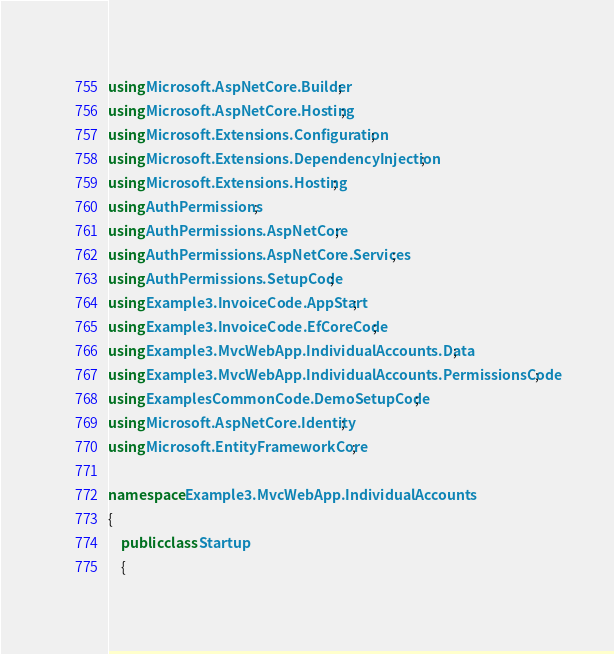Convert code to text. <code><loc_0><loc_0><loc_500><loc_500><_C#_>using Microsoft.AspNetCore.Builder;
using Microsoft.AspNetCore.Hosting;
using Microsoft.Extensions.Configuration;
using Microsoft.Extensions.DependencyInjection;
using Microsoft.Extensions.Hosting;
using AuthPermissions;
using AuthPermissions.AspNetCore;
using AuthPermissions.AspNetCore.Services;
using AuthPermissions.SetupCode;
using Example3.InvoiceCode.AppStart;
using Example3.InvoiceCode.EfCoreCode;
using Example3.MvcWebApp.IndividualAccounts.Data;
using Example3.MvcWebApp.IndividualAccounts.PermissionsCode;
using ExamplesCommonCode.DemoSetupCode;
using Microsoft.AspNetCore.Identity;
using Microsoft.EntityFrameworkCore;

namespace Example3.MvcWebApp.IndividualAccounts
{
    public class Startup
    {</code> 